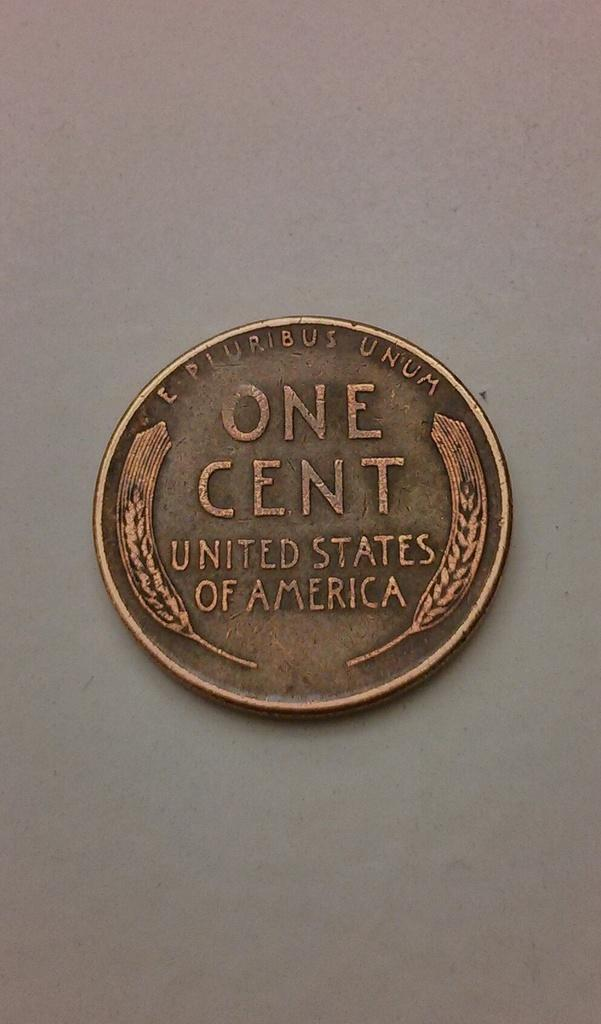<image>
Provide a brief description of the given image. A one cent coin for the United Stated of America. 